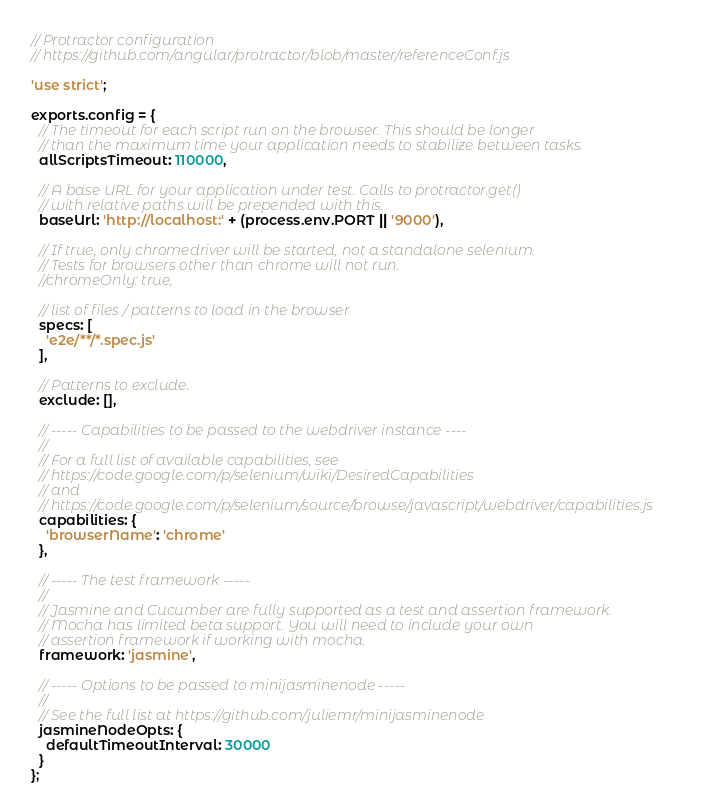Convert code to text. <code><loc_0><loc_0><loc_500><loc_500><_JavaScript_>// Protractor configuration
// https://github.com/angular/protractor/blob/master/referenceConf.js

'use strict';

exports.config = {
  // The timeout for each script run on the browser. This should be longer
  // than the maximum time your application needs to stabilize between tasks.
  allScriptsTimeout: 110000,

  // A base URL for your application under test. Calls to protractor.get()
  // with relative paths will be prepended with this.
  baseUrl: 'http://localhost:' + (process.env.PORT || '9000'),

  // If true, only chromedriver will be started, not a standalone selenium.
  // Tests for browsers other than chrome will not run.
  //chromeOnly: true,

  // list of files / patterns to load in the browser
  specs: [
    'e2e/**/*.spec.js'
  ],

  // Patterns to exclude.
  exclude: [],

  // ----- Capabilities to be passed to the webdriver instance ----
  //
  // For a full list of available capabilities, see
  // https://code.google.com/p/selenium/wiki/DesiredCapabilities
  // and
  // https://code.google.com/p/selenium/source/browse/javascript/webdriver/capabilities.js
  capabilities: {
    'browserName': 'chrome'
  },

  // ----- The test framework -----
  //
  // Jasmine and Cucumber are fully supported as a test and assertion framework.
  // Mocha has limited beta support. You will need to include your own
  // assertion framework if working with mocha.
  framework: 'jasmine',

  // ----- Options to be passed to minijasminenode -----
  //
  // See the full list at https://github.com/juliemr/minijasminenode
  jasmineNodeOpts: {
    defaultTimeoutInterval: 30000
  }
};
</code> 